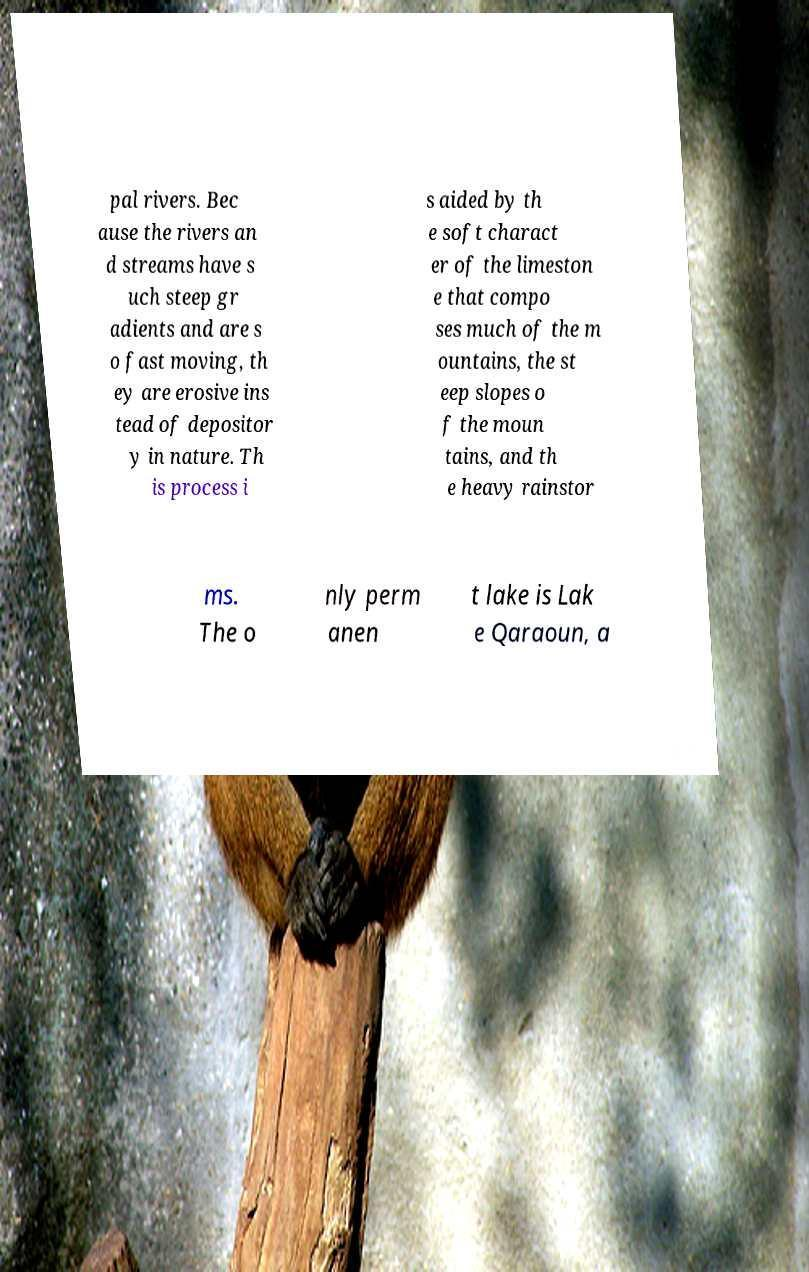There's text embedded in this image that I need extracted. Can you transcribe it verbatim? pal rivers. Bec ause the rivers an d streams have s uch steep gr adients and are s o fast moving, th ey are erosive ins tead of depositor y in nature. Th is process i s aided by th e soft charact er of the limeston e that compo ses much of the m ountains, the st eep slopes o f the moun tains, and th e heavy rainstor ms. The o nly perm anen t lake is Lak e Qaraoun, a 